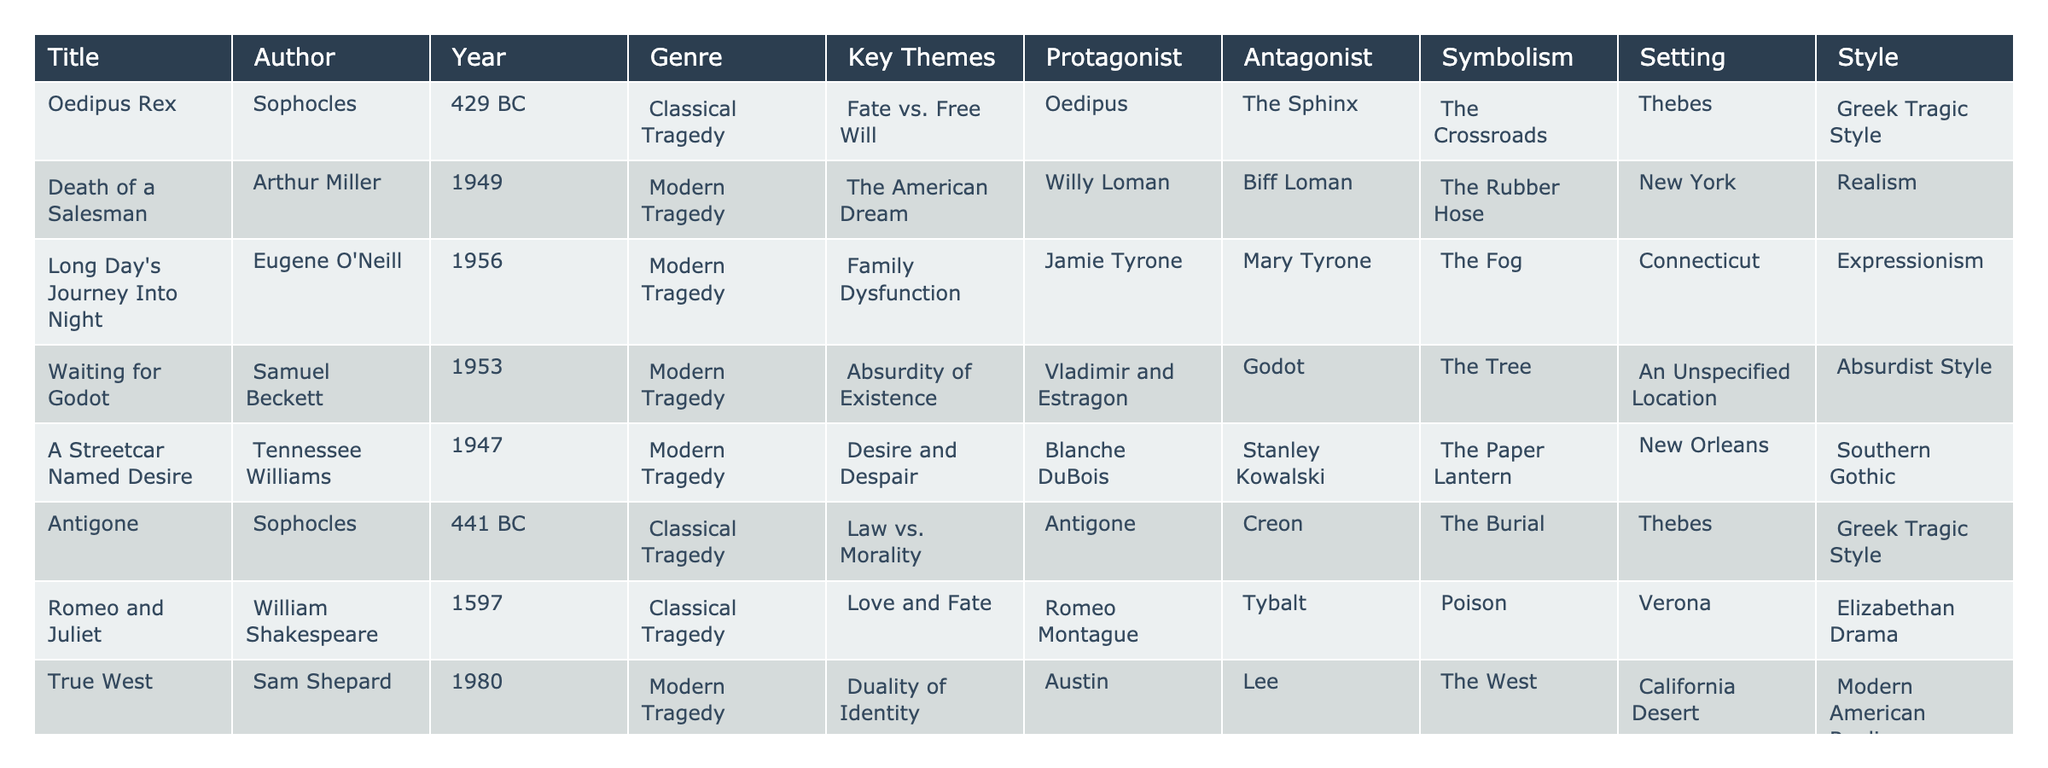What are the key themes of "Oedipus Rex"? The table indicates that the key themes of "Oedipus Rex" are Fate vs. Free Will, as specified in the "Key Themes" column for this title.
Answer: Fate vs. Free Will Who is the protagonist in "Death of a Salesman"? The table lists Willy Loman as the protagonist of "Death of a Salesman" in the "Protagonist" column.
Answer: Willy Loman How many modern tragedy plays are listed? The table shows five plays categorized under Modern Tragedy: "Death of a Salesman," "Long Day's Journey Into Night," "Waiting for Godot," "A Streetcar Named Desire," and "True West." Counting these, there are five modern tragedy plays.
Answer: 5 Which classical tragedy has the antagonist "Creon"? Referring to the table, "Antigone" is the classical tragedy with Creon as the antagonist, as noted in the "Antagonist" column.
Answer: Antigone Is "Waiting for Godot" set in a specific location? The table states that "Waiting for Godot" is set in an unspecified location, as noted under the "Setting" column.
Answer: No What is the symbolism used in "Macbeth"? According to the table, the symbolism in "Macbeth" is represented by "The Dagger," as stated in the "Symbolism" column for this play.
Answer: The Dagger How does the setting of "A Streetcar Named Desire" differ from that of "Oedipus Rex"? From the table, "A Streetcar Named Desire" is set in New Orleans while "Oedipus Rex" takes place in Thebes. The difference lies in the geographical locations: New Orleans is a contemporary urban setting, and Thebes is an ancient Greek city.
Answer: Different locations: New Orleans vs. Thebes What is the common theme among the modern tragedies listed? Analyzing the key themes of the modern tragedies, they revolve around personal and societal issues like disillusionment, family dysfunction, and absurdity of existence, suggesting a focus on contemporary human experiences and conflicts.
Answer: Contemporary human experiences Which play has the symbolism of "The Fog"? The table indicates that "Long Day's Journey Into Night" employs "The Fog" as its symbolism, as seen in the "Symbolism" column for this play.
Answer: Long Day's Journey Into Night Which author is associated with the theme of "The American Dream"? Referring to the table, Arthur Miller is the author associated with the theme of "The American Dream," evident in the "Key Themes" column for "Death of a Salesman."
Answer: Arthur Miller What are the differences in styles between classical and modern tragedies in the table? The styles differ significantly: classical tragedies like "Oedipus Rex" and "Macbeth" utilize Greek Tragic Style and Elizabethan Drama respectively, while modern tragedies like "Death of a Salesman" and "Long Day's Journey Into Night" employ Realism and Expressionism. This indicates a shift towards more relatable or realistic portrayals of human experiences.
Answer: Greek Tragic Style vs. Realism/Expressionism What is the average year of publication for the classical tragedies? The classical tragedies are from 429 BC (Oedipus Rex), 441 BC (Antigone), and 1597 (Romeo and Juliet). To find the average: convert the BC years to negative values, sum them (−429 + −441 + 1597 = 727), and divide by 3, giving an average year of approximately 242 BC.
Answer: 242 BC What role does the antagonist play in "True West"? In "True West," the antagonist is Lee, who has a confrontational and competitive relationship with the protagonist, Austin. Lee symbolizes chaos and a challenge to Austin's life. This reflects the theme of duality of identity and familial conflict evidenced in the table.
Answer: Lee represents chaos and competition 